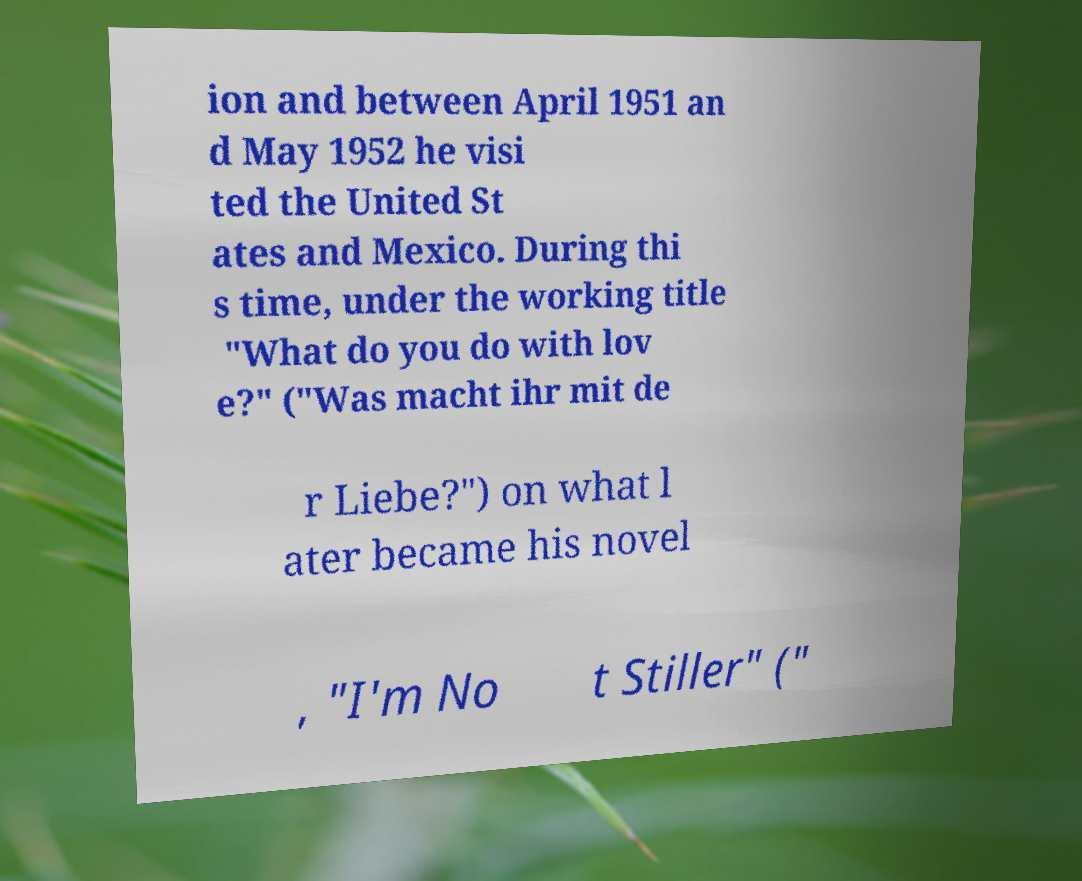For documentation purposes, I need the text within this image transcribed. Could you provide that? ion and between April 1951 an d May 1952 he visi ted the United St ates and Mexico. During thi s time, under the working title "What do you do with lov e?" ("Was macht ihr mit de r Liebe?") on what l ater became his novel , "I'm No t Stiller" (" 